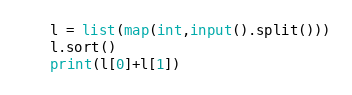Convert code to text. <code><loc_0><loc_0><loc_500><loc_500><_Python_>l = list(map(int,input().split()))
l.sort()
print(l[0]+l[1])
</code> 